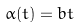<formula> <loc_0><loc_0><loc_500><loc_500>\alpha ( t ) = b t</formula> 